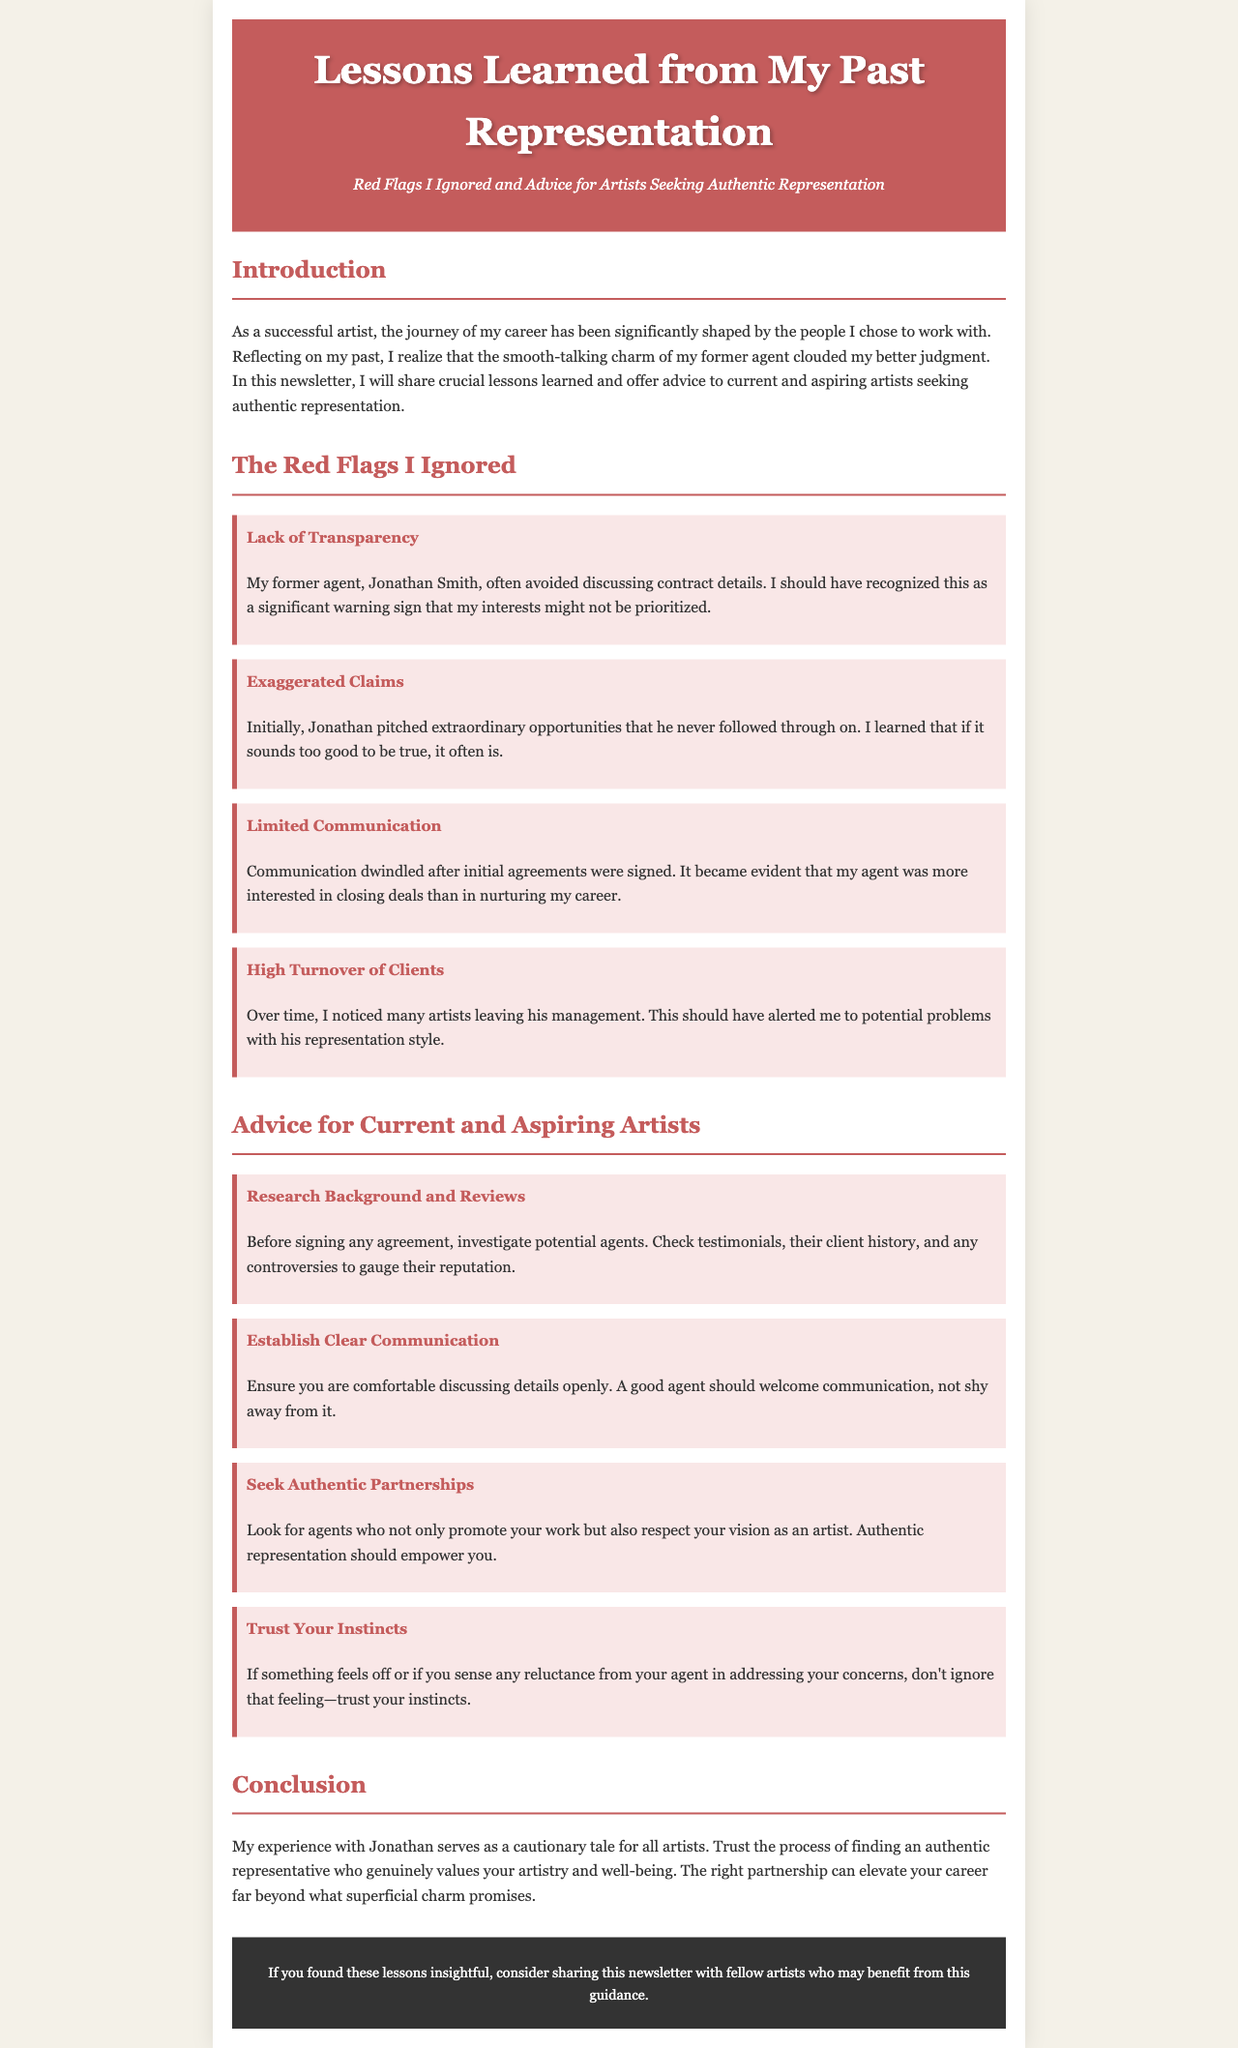What is the name of the former agent? The document mentions the name of the former agent as Jonathan Smith.
Answer: Jonathan Smith How many red flags are identified in the newsletter? The document lists four red flags that the artist ignored while working with their former agent.
Answer: Four What is one example of a red flag mentioned? The document provides several examples, such as 'Lack of Transparency.'
Answer: Lack of Transparency What advice is given regarding communication? The newsletter explicitly states that clear communication should be established with an agent.
Answer: Establish Clear Communication What is the background color of the document? The background color specified in the CSS is a light beige shade, described in the style section of the code.
Answer: Light beige What type of partnership does the artist suggest seeking? The document advises artists to seek authentic partnerships with their agents.
Answer: Authentic partnerships Which section discusses specific warnings from the past? The section focused on red flags discusses the specific warnings the artist faced.
Answer: The Red Flags I Ignored What is the subtitle of the newsletter? The subtitle summarizes the main theme of the document, focusing on red flags and advice.
Answer: Red Flags I Ignored and Advice for Artists Seeking Authentic Representation 